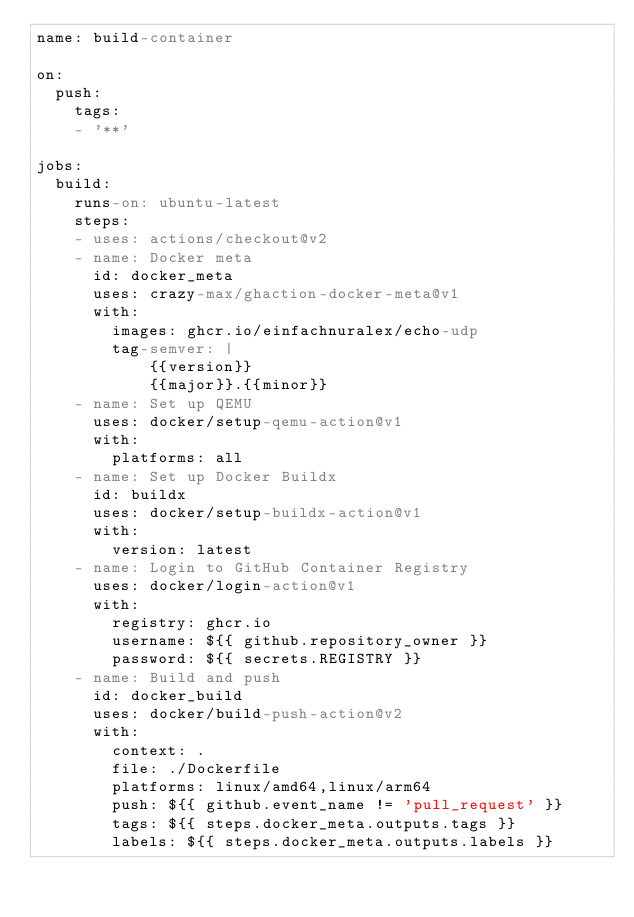<code> <loc_0><loc_0><loc_500><loc_500><_YAML_>name: build-container

on:
  push:
    tags:
    - '**'

jobs:
  build:
    runs-on: ubuntu-latest
    steps:
    - uses: actions/checkout@v2
    - name: Docker meta
      id: docker_meta
      uses: crazy-max/ghaction-docker-meta@v1
      with:
        images: ghcr.io/einfachnuralex/echo-udp
        tag-semver: |
            {{version}}
            {{major}}.{{minor}}
    - name: Set up QEMU
      uses: docker/setup-qemu-action@v1
      with:
        platforms: all
    - name: Set up Docker Buildx
      id: buildx
      uses: docker/setup-buildx-action@v1
      with:
        version: latest
    - name: Login to GitHub Container Registry
      uses: docker/login-action@v1
      with:
        registry: ghcr.io
        username: ${{ github.repository_owner }}
        password: ${{ secrets.REGISTRY }}
    - name: Build and push
      id: docker_build
      uses: docker/build-push-action@v2
      with:
        context: .
        file: ./Dockerfile
        platforms: linux/amd64,linux/arm64
        push: ${{ github.event_name != 'pull_request' }}
        tags: ${{ steps.docker_meta.outputs.tags }}
        labels: ${{ steps.docker_meta.outputs.labels }}</code> 